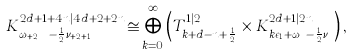Convert formula to latex. <formula><loc_0><loc_0><loc_500><loc_500>K ^ { 2 d + 1 + 4 n | 4 d + 2 + 2 n } _ { \omega _ { d + 2 n } - \frac { 1 } { 2 } \nu _ { n + 2 d + 1 } } \cong \bigoplus _ { k = 0 } ^ { \infty } \left ( T ^ { 1 | 2 } _ { k + d - n + \frac { 1 } { 2 } } \times K ^ { 2 d + 1 | 2 n } _ { k \epsilon _ { 1 } + \omega _ { d } - \frac { 1 } { 2 } \nu _ { n } } \right ) ,</formula> 